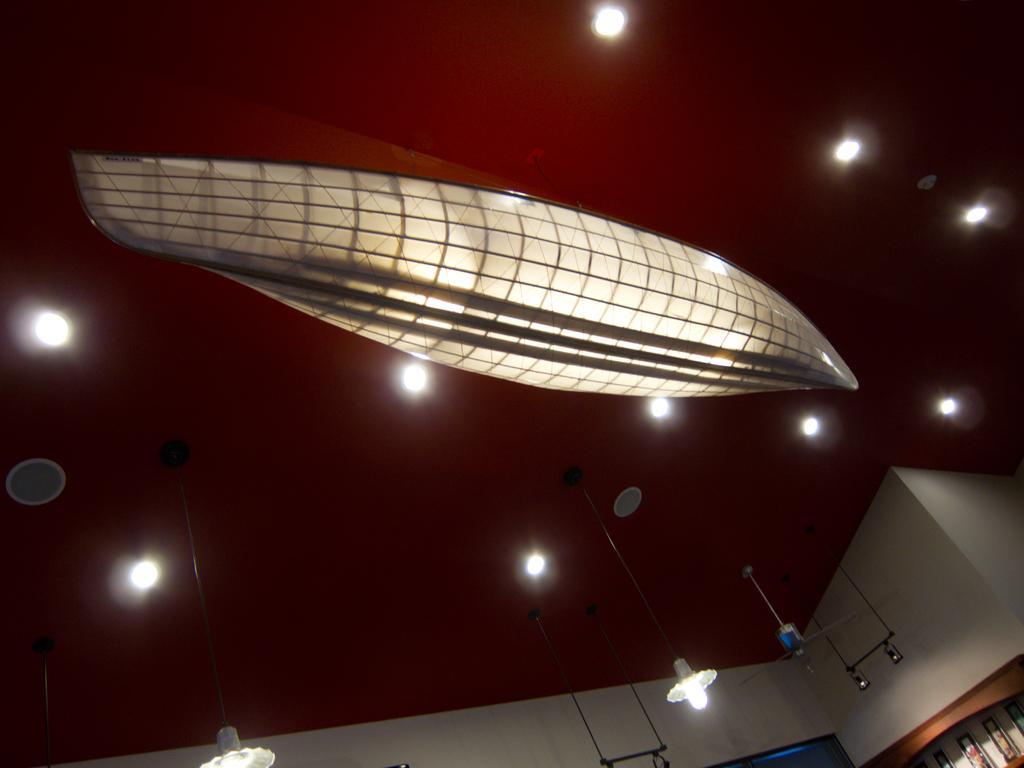Could you give a brief overview of what you see in this image? In this image we can see an inside view of a room. In the foreground we can see photo frames on the wall. In the background, we can see group of lights. 